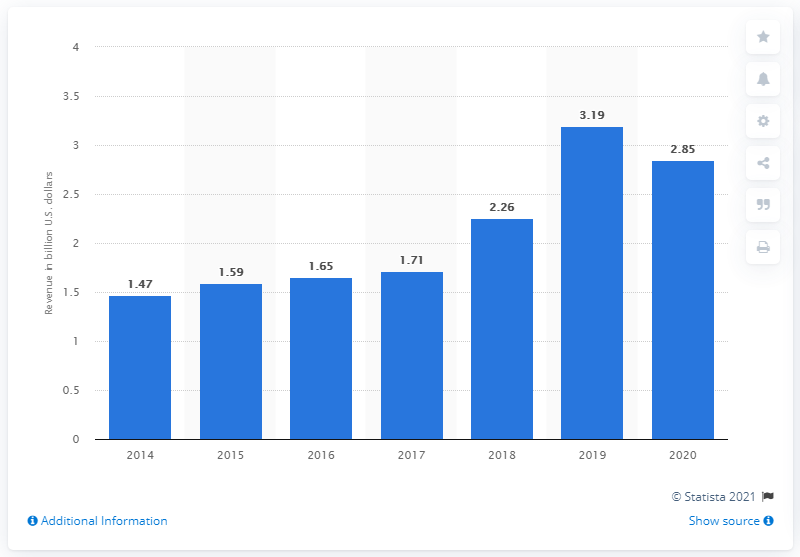Give some essential details in this illustration. In 2019, Meredith Corporation's annual revenue was approximately 3.19 billion US dollars. 